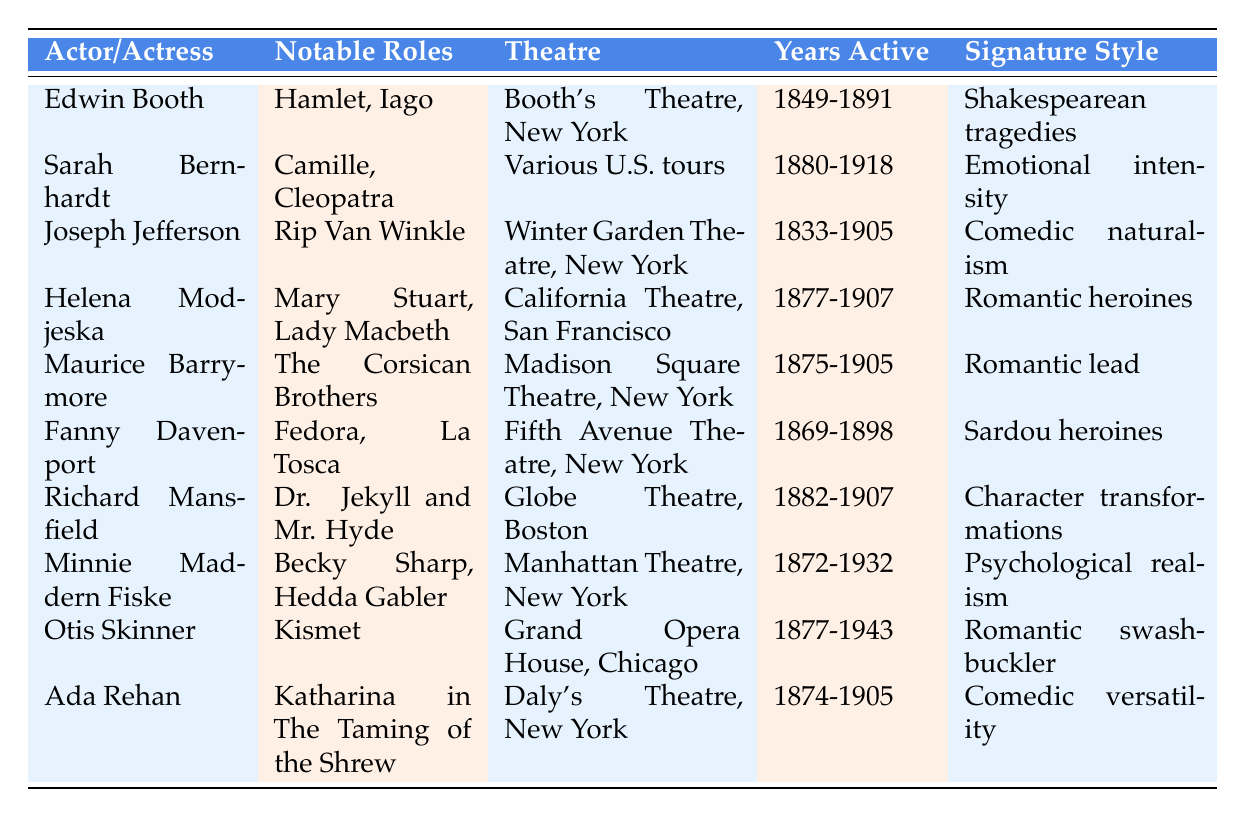What notable role did Edwin Booth play? Edwin Booth's notable roles listed in the table are Hamlet and Iago.
Answer: Hamlet, Iago Which actress is known for her emotional intensity? The table indicates that Sarah Bernhardt is known for her emotional intensity in her performances.
Answer: Sarah Bernhardt How many years did Joseph Jefferson's career span? Joseph Jefferson's active years are from 1833 to 1905. To find the number of years, calculate 1905 - 1833 = 72 years.
Answer: 72 Is Richard Mansfield associated with any romantic heroines? According to the table, Richard Mansfield is known for character transformations, not specifically romantic heroines. Therefore, the answer is no.
Answer: No Which actor had the longest active career? Among the actors listed, Minnie Maddern Fiske was active from 1872 to 1932, which totals 60 years. Others, such as Edwin Booth (42 years), Joseph Jefferson (72 years), and Otis Skinner (66 years), had shorter careers. Thus, Minnie Maddern Fiske has the longest active tenure.
Answer: Minnie Maddern Fiske What is the signature style of Ada Rehan? The table states that Ada Rehan's signature style is characterized by comedic versatility.
Answer: Comedic versatility Did any of these performers primarily work in New York theatres? The table shows that Edwin Booth, Joseph Jefferson, Maurice Barrymore, Fanny Davenport, Richard Mansfield, Minnie Maddern Fiske, and Ada Rehan primarily worked at theatres located in New York. Thus, the answer is yes.
Answer: Yes How many actors mentioned in the table performed in the late 19th century and were active until 1900 or later? From the data, Edwin Booth, Sarah Bernhardt, Joseph Jefferson, Helena Modjeska, Maurice Barrymore, Richard Mansfield, Minnie Maddern Fiske, and Otis Skinner fall into this category. Counting them, we find there are 8 such actors.
Answer: 8 Which performer played the role of Dr. Jekyll and Mr. Hyde? The table clearly lists Richard Mansfield as the performer who played the role of Dr. Jekyll and Mr. Hyde.
Answer: Richard Mansfield 